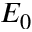Convert formula to latex. <formula><loc_0><loc_0><loc_500><loc_500>E _ { 0 }</formula> 